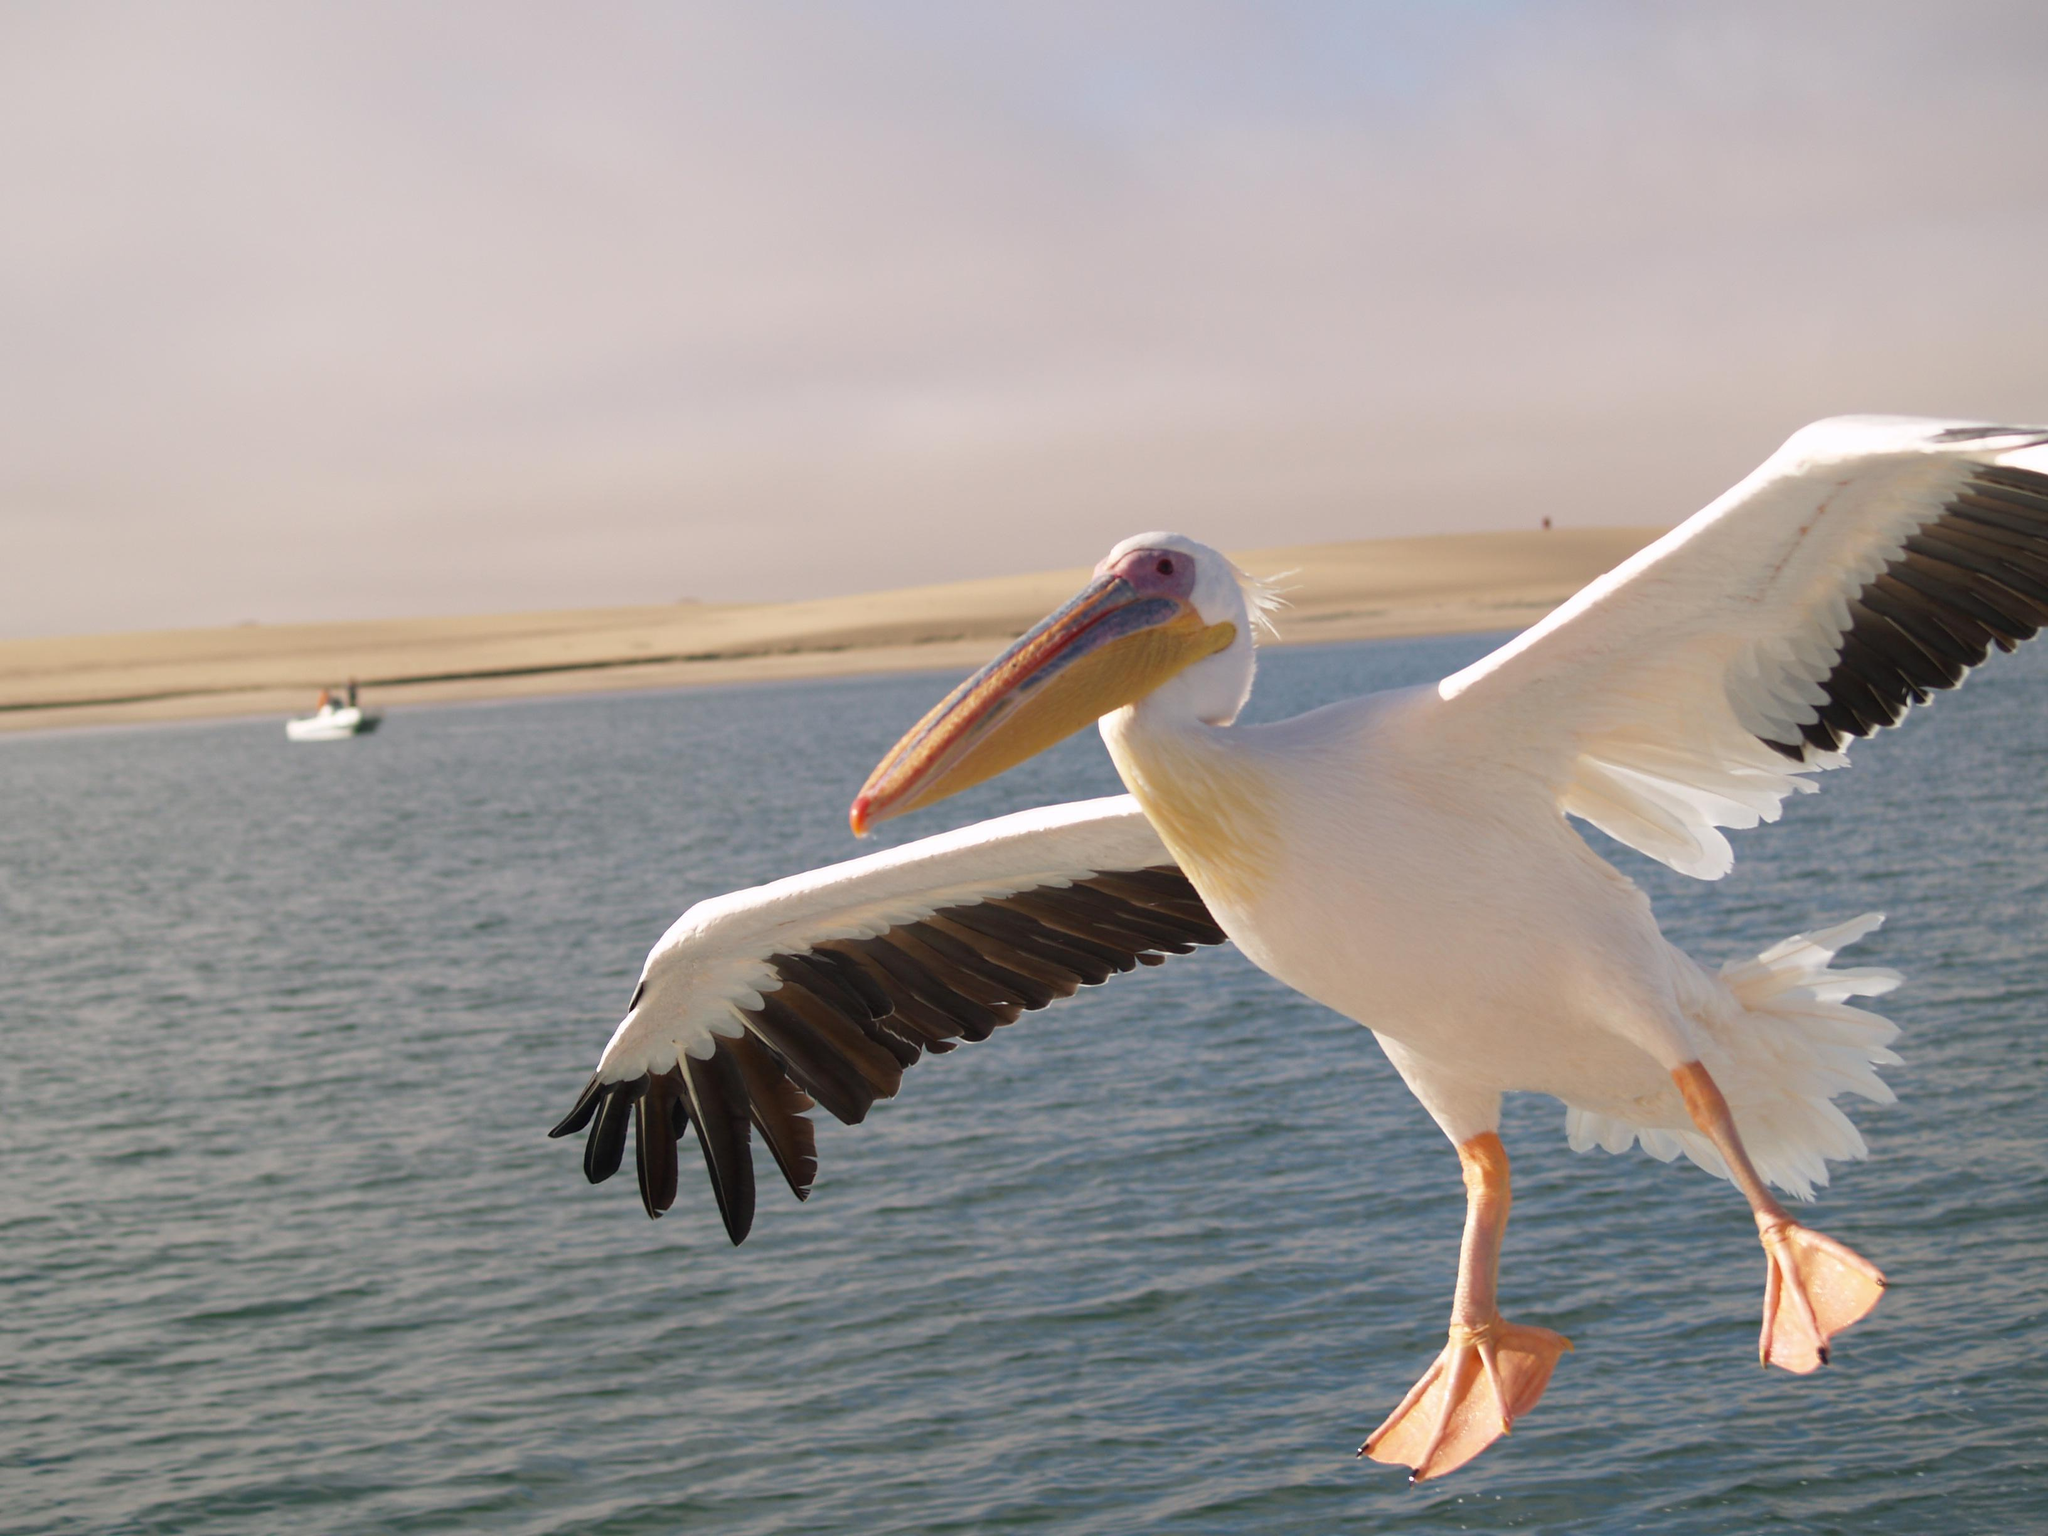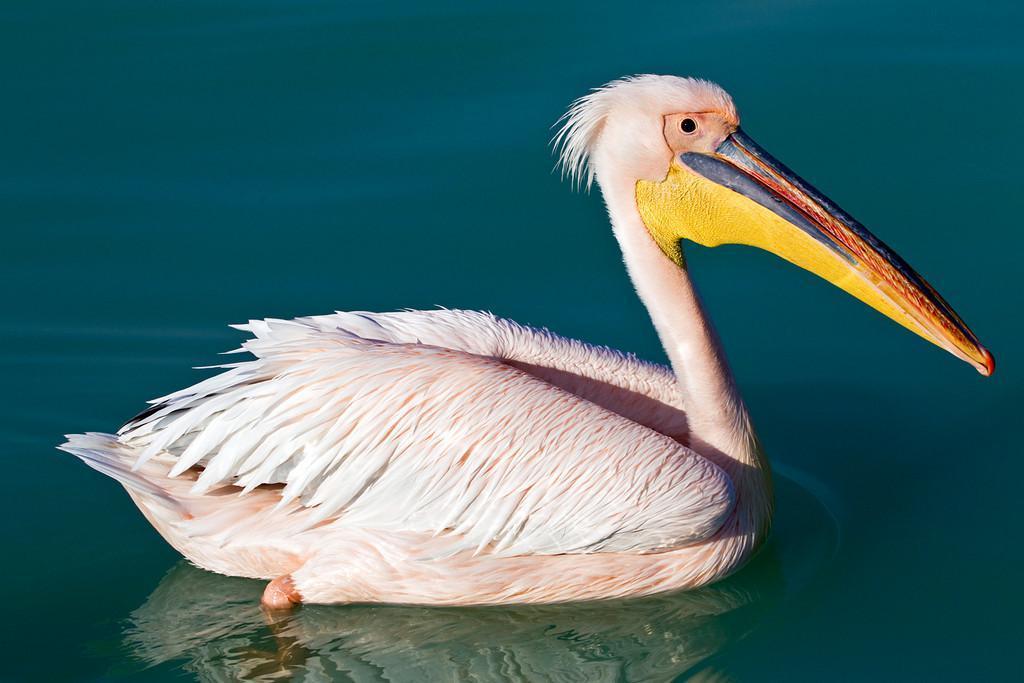The first image is the image on the left, the second image is the image on the right. Given the left and right images, does the statement "There are more than 5 pelicans facing right." hold true? Answer yes or no. No. The first image is the image on the left, the second image is the image on the right. For the images shown, is this caption "A group of spectators are observing the pelicans." true? Answer yes or no. No. 